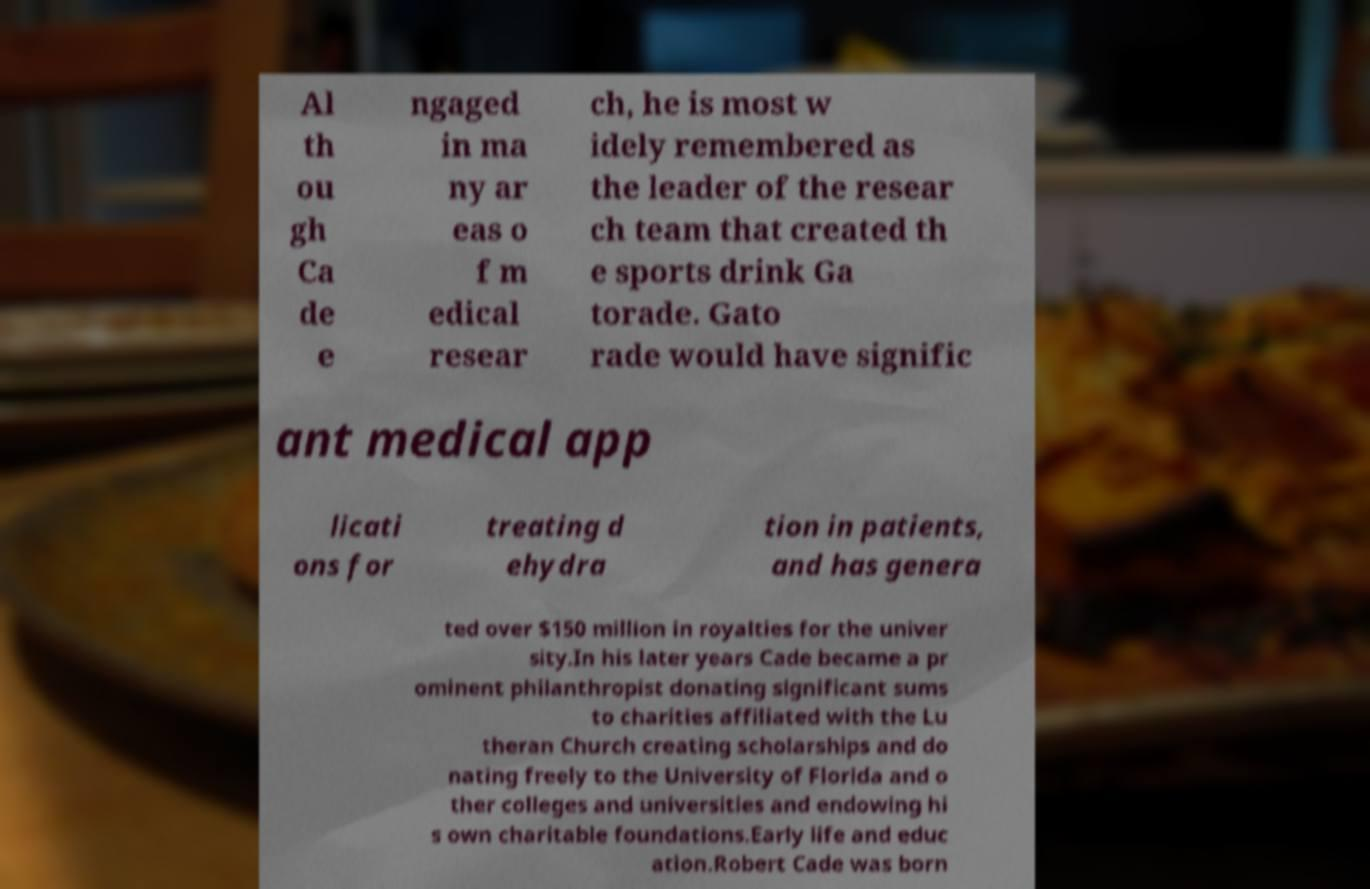I need the written content from this picture converted into text. Can you do that? Al th ou gh Ca de e ngaged in ma ny ar eas o f m edical resear ch, he is most w idely remembered as the leader of the resear ch team that created th e sports drink Ga torade. Gato rade would have signific ant medical app licati ons for treating d ehydra tion in patients, and has genera ted over $150 million in royalties for the univer sity.In his later years Cade became a pr ominent philanthropist donating significant sums to charities affiliated with the Lu theran Church creating scholarships and do nating freely to the University of Florida and o ther colleges and universities and endowing hi s own charitable foundations.Early life and educ ation.Robert Cade was born 